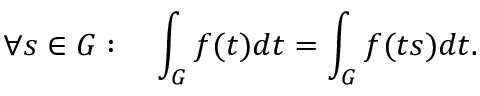Convert formula to latex. <formula><loc_0><loc_0><loc_500><loc_500>\forall s \in G \colon \quad \int _ { G } f ( t ) d t = \int _ { G } f ( t s ) d t .</formula> 